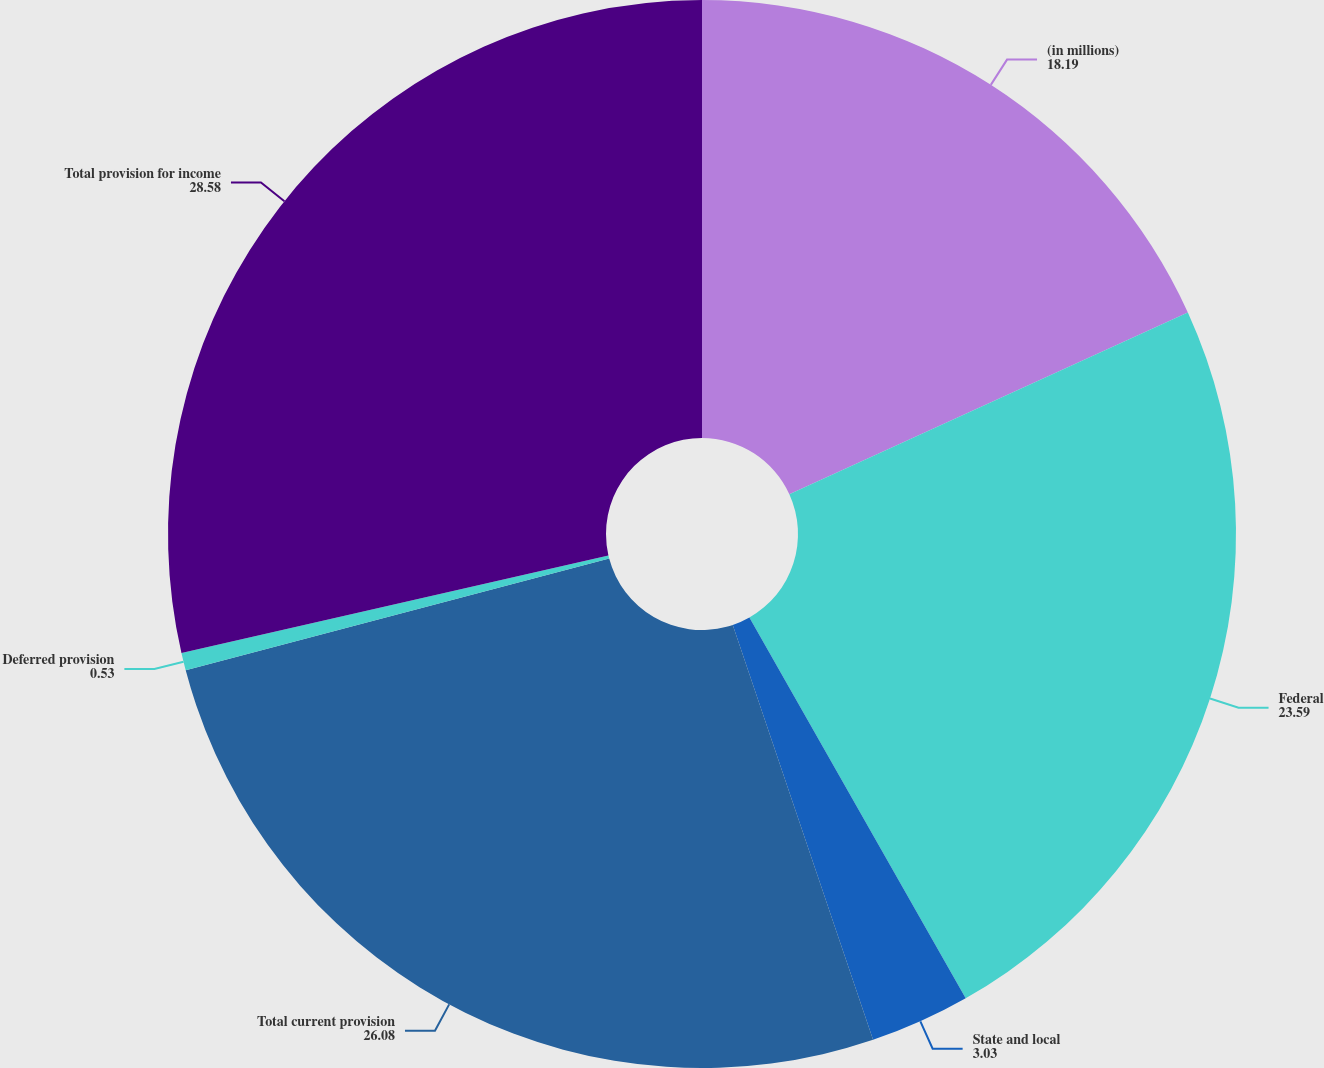<chart> <loc_0><loc_0><loc_500><loc_500><pie_chart><fcel>(in millions)<fcel>Federal<fcel>State and local<fcel>Total current provision<fcel>Deferred provision<fcel>Total provision for income<nl><fcel>18.19%<fcel>23.59%<fcel>3.03%<fcel>26.08%<fcel>0.53%<fcel>28.58%<nl></chart> 